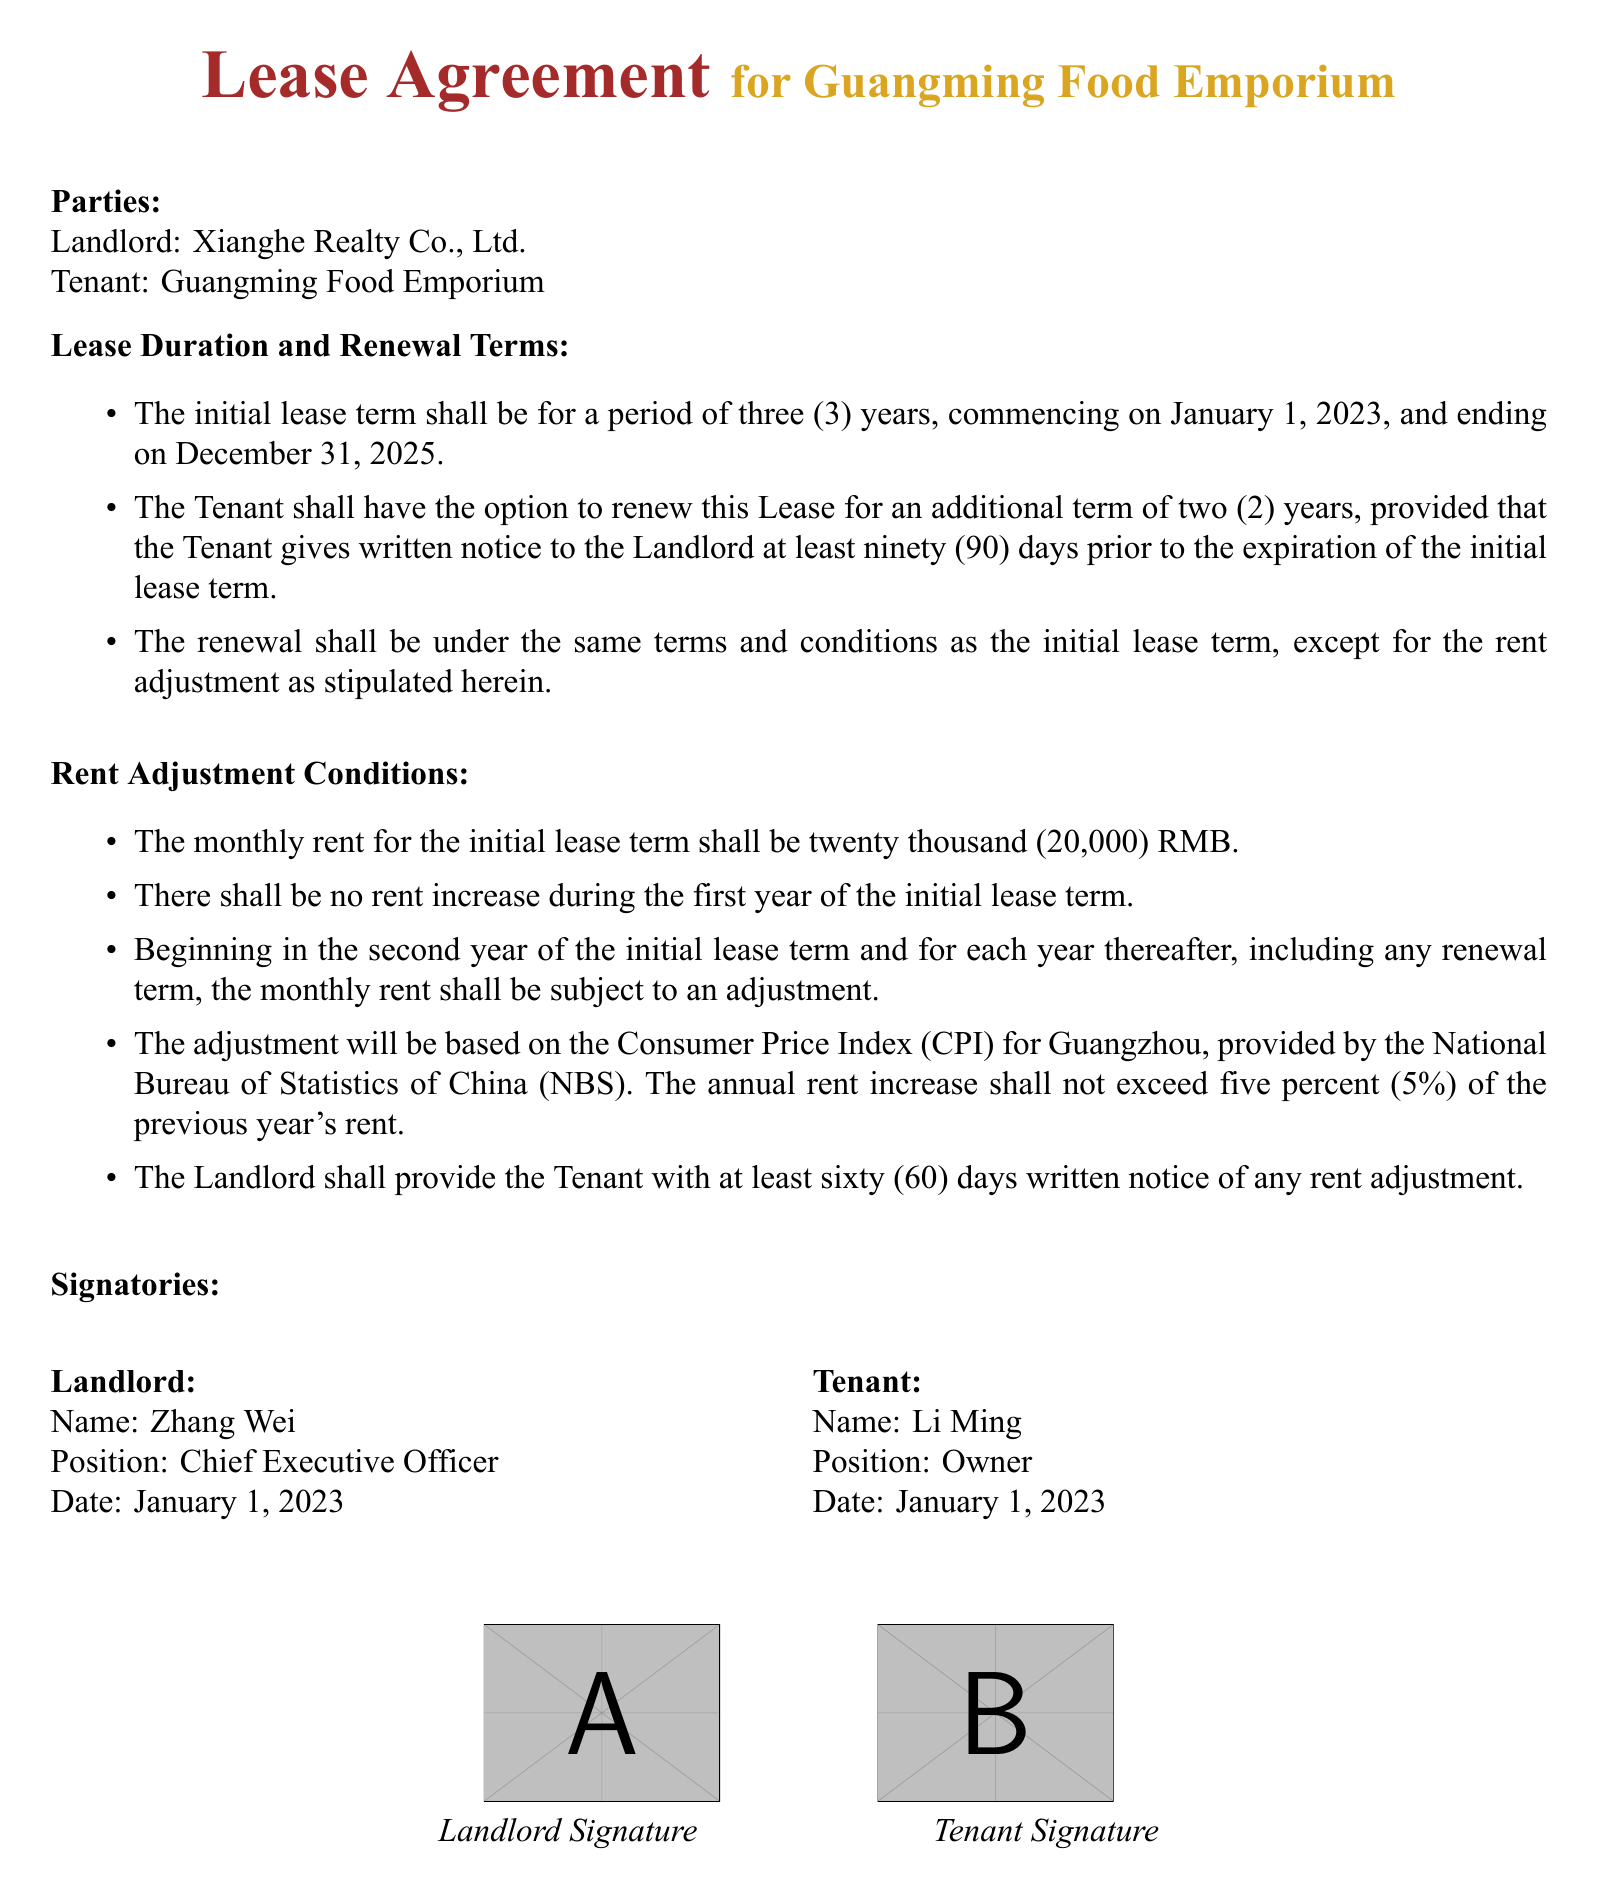what is the initial lease term? The initial lease term is specified in the document, indicating its duration from the start date to the end date.
Answer: three (3) years when does the lease commence? The lease commencement date is clearly stated in the document.
Answer: January 1, 2023 what is the monthly rent during the initial lease term? The document specifies the rent amount that the tenant is required to pay each month for the initial term.
Answer: twenty thousand (20,000) RMB is there a rent increase during the first year? The document explicitly mentions whether there will be an increase in rent in the initial year.
Answer: no how much notice must the tenant give for lease renewal? The document details the notice period required from the tenant before the lease expiration for renewal.
Answer: ninety (90) days what is the maximum allowable annual rent increase? The document outlines the conditions for rent adjustment and specifies the limit on rent increases each year.
Answer: five percent (5%) who is the landlord? The name of the landlord is explicitly stated in the document under the parties section.
Answer: Xianghe Realty Co., Ltd how long is the renewal term? The document states the duration of the renewal option available to the tenant.
Answer: two (2) years what must the landlord provide before a rent adjustment? The document requires the landlord to give specific information before making adjustments to the rent.
Answer: sixty (60) days written notice 